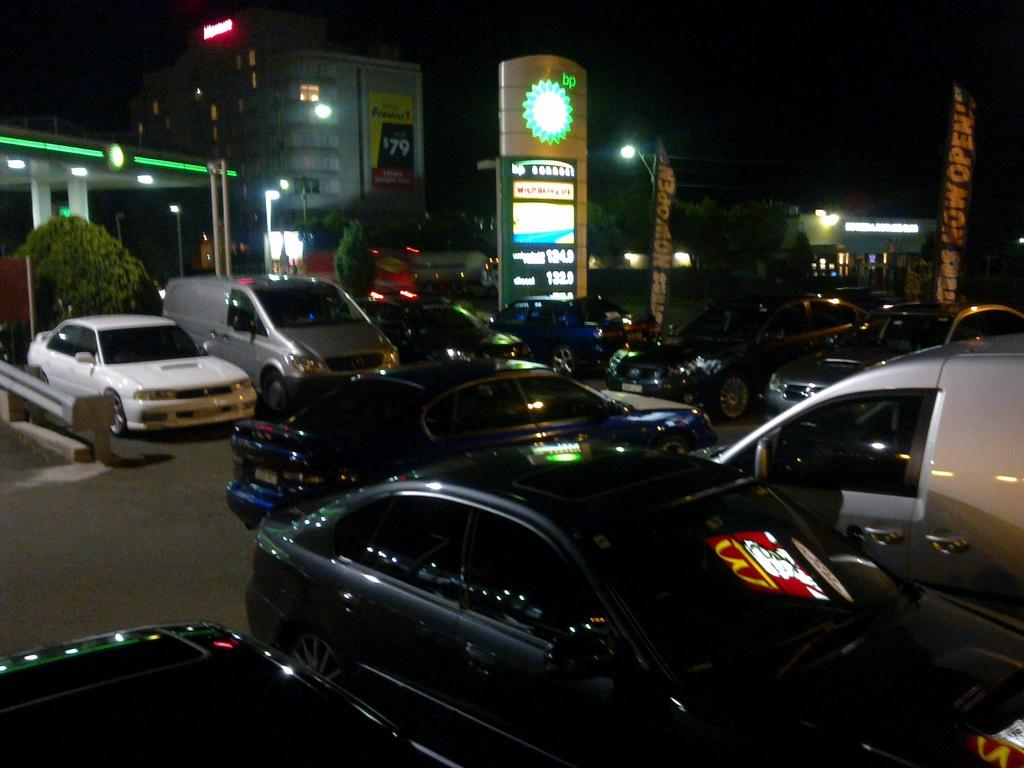What can be seen on the road in the image? There are vehicles on the road in the image. What objects are present alongside the road? There are poles in the image. What can be found on the poles? There are lights in the image. What type of structures can be seen in the image? There are houses in the image. What type of vegetation is present in the image? There are trees in the image. What is visible in the background of the image? The sky is visible in the background of the image. Where is the bottle hidden in the image? There is no bottle present in the image. What type of line can be seen connecting the houses in the image? There is no line connecting the houses in the image. 